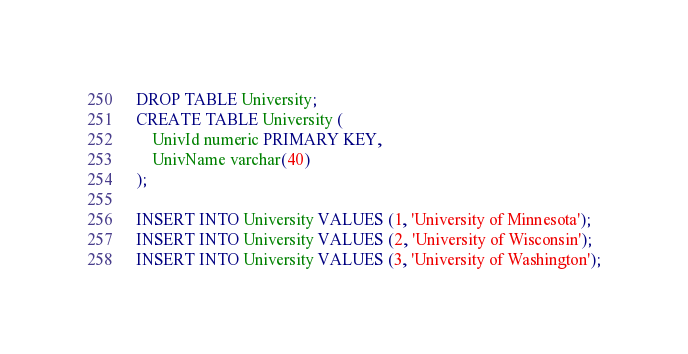Convert code to text. <code><loc_0><loc_0><loc_500><loc_500><_SQL_>DROP TABLE University;
CREATE TABLE University (
	UnivId numeric PRIMARY KEY,
	UnivName varchar(40)
);

INSERT INTO University VALUES (1, 'University of Minnesota');
INSERT INTO University VALUES (2, 'University of Wisconsin');
INSERT INTO University VALUES (3, 'University of Washington');</code> 